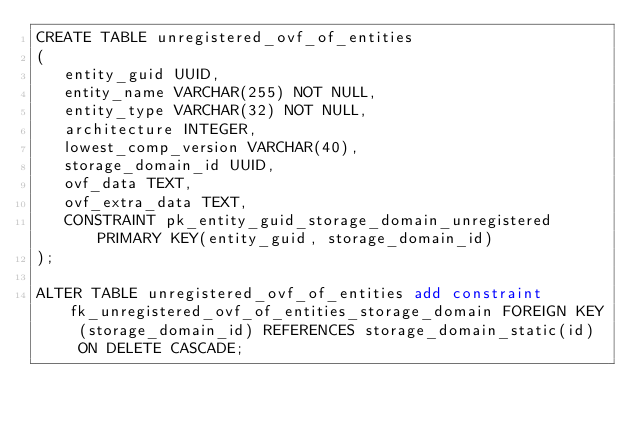Convert code to text. <code><loc_0><loc_0><loc_500><loc_500><_SQL_>CREATE TABLE unregistered_ovf_of_entities
(
   entity_guid UUID,
   entity_name VARCHAR(255) NOT NULL,
   entity_type VARCHAR(32) NOT NULL,
   architecture INTEGER,
   lowest_comp_version VARCHAR(40),
   storage_domain_id UUID,
   ovf_data TEXT,
   ovf_extra_data TEXT,
   CONSTRAINT pk_entity_guid_storage_domain_unregistered PRIMARY KEY(entity_guid, storage_domain_id)
);

ALTER TABLE unregistered_ovf_of_entities add constraint fk_unregistered_ovf_of_entities_storage_domain FOREIGN KEY (storage_domain_id) REFERENCES storage_domain_static(id)  ON DELETE CASCADE;
</code> 